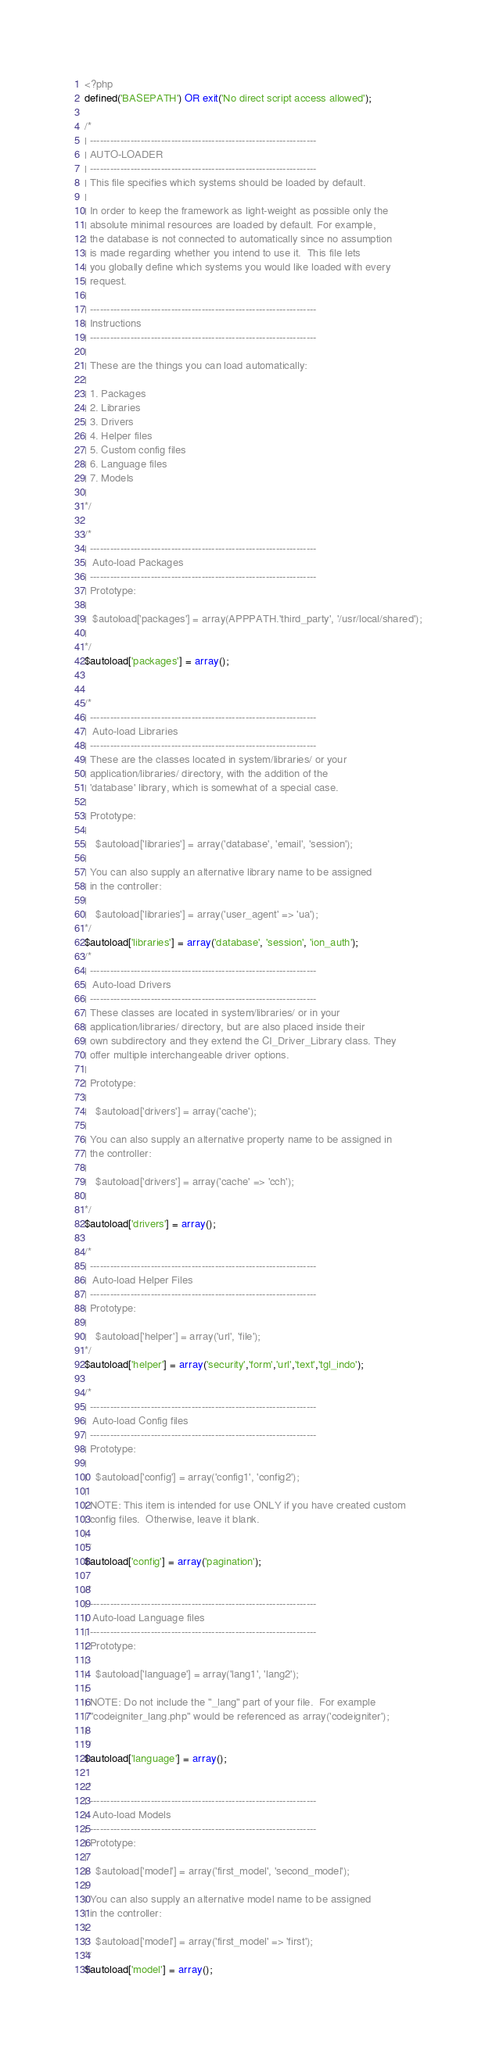<code> <loc_0><loc_0><loc_500><loc_500><_PHP_><?php
defined('BASEPATH') OR exit('No direct script access allowed');

/*
| -------------------------------------------------------------------
| AUTO-LOADER
| -------------------------------------------------------------------
| This file specifies which systems should be loaded by default.
|
| In order to keep the framework as light-weight as possible only the
| absolute minimal resources are loaded by default. For example,
| the database is not connected to automatically since no assumption
| is made regarding whether you intend to use it.  This file lets
| you globally define which systems you would like loaded with every
| request.
|
| -------------------------------------------------------------------
| Instructions
| -------------------------------------------------------------------
|
| These are the things you can load automatically:
|
| 1. Packages
| 2. Libraries
| 3. Drivers
| 4. Helper files
| 5. Custom config files
| 6. Language files
| 7. Models
|
*/

/*
| -------------------------------------------------------------------
|  Auto-load Packages
| -------------------------------------------------------------------
| Prototype:
|
|  $autoload['packages'] = array(APPPATH.'third_party', '/usr/local/shared');
|
*/
$autoload['packages'] = array();


/*
| -------------------------------------------------------------------
|  Auto-load Libraries
| -------------------------------------------------------------------
| These are the classes located in system/libraries/ or your
| application/libraries/ directory, with the addition of the
| 'database' library, which is somewhat of a special case.
|
| Prototype:
|
|	$autoload['libraries'] = array('database', 'email', 'session');
|
| You can also supply an alternative library name to be assigned
| in the controller:
|
|	$autoload['libraries'] = array('user_agent' => 'ua');
*/
$autoload['libraries'] = array('database', 'session', 'ion_auth');
/*
| -------------------------------------------------------------------
|  Auto-load Drivers
| -------------------------------------------------------------------
| These classes are located in system/libraries/ or in your
| application/libraries/ directory, but are also placed inside their
| own subdirectory and they extend the CI_Driver_Library class. They
| offer multiple interchangeable driver options.
|
| Prototype:
|
|	$autoload['drivers'] = array('cache');
|
| You can also supply an alternative property name to be assigned in
| the controller:
|
|	$autoload['drivers'] = array('cache' => 'cch');
|
*/
$autoload['drivers'] = array();

/*
| -------------------------------------------------------------------
|  Auto-load Helper Files
| -------------------------------------------------------------------
| Prototype:
|
|	$autoload['helper'] = array('url', 'file');
*/
$autoload['helper'] = array('security','form','url','text','tgl_indo');

/*
| -------------------------------------------------------------------
|  Auto-load Config files
| -------------------------------------------------------------------
| Prototype:
|
|	$autoload['config'] = array('config1', 'config2');
|
| NOTE: This item is intended for use ONLY if you have created custom
| config files.  Otherwise, leave it blank.
|
*/
$autoload['config'] = array('pagination');

/*
| -------------------------------------------------------------------
|  Auto-load Language files
| -------------------------------------------------------------------
| Prototype:
|
|	$autoload['language'] = array('lang1', 'lang2');
|
| NOTE: Do not include the "_lang" part of your file.  For example
| "codeigniter_lang.php" would be referenced as array('codeigniter');
|
*/
$autoload['language'] = array();

/*
| -------------------------------------------------------------------
|  Auto-load Models
| -------------------------------------------------------------------
| Prototype:
|
|	$autoload['model'] = array('first_model', 'second_model');
|
| You can also supply an alternative model name to be assigned
| in the controller:
|
|	$autoload['model'] = array('first_model' => 'first');
*/
$autoload['model'] = array();
</code> 